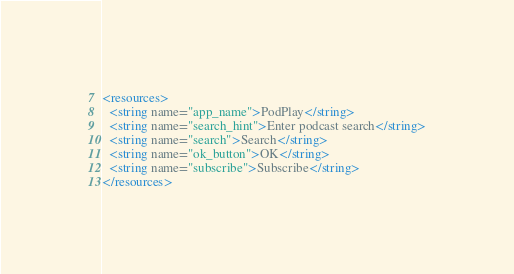Convert code to text. <code><loc_0><loc_0><loc_500><loc_500><_XML_><resources>
  <string name="app_name">PodPlay</string>
  <string name="search_hint">Enter podcast search</string>
  <string name="search">Search</string>
  <string name="ok_button">OK</string>
  <string name="subscribe">Subscribe</string>
</resources>
</code> 